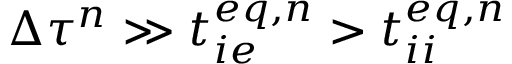<formula> <loc_0><loc_0><loc_500><loc_500>\Delta \tau ^ { n } \gg t _ { i e } ^ { e q , n } > t _ { i i } ^ { e q , n }</formula> 